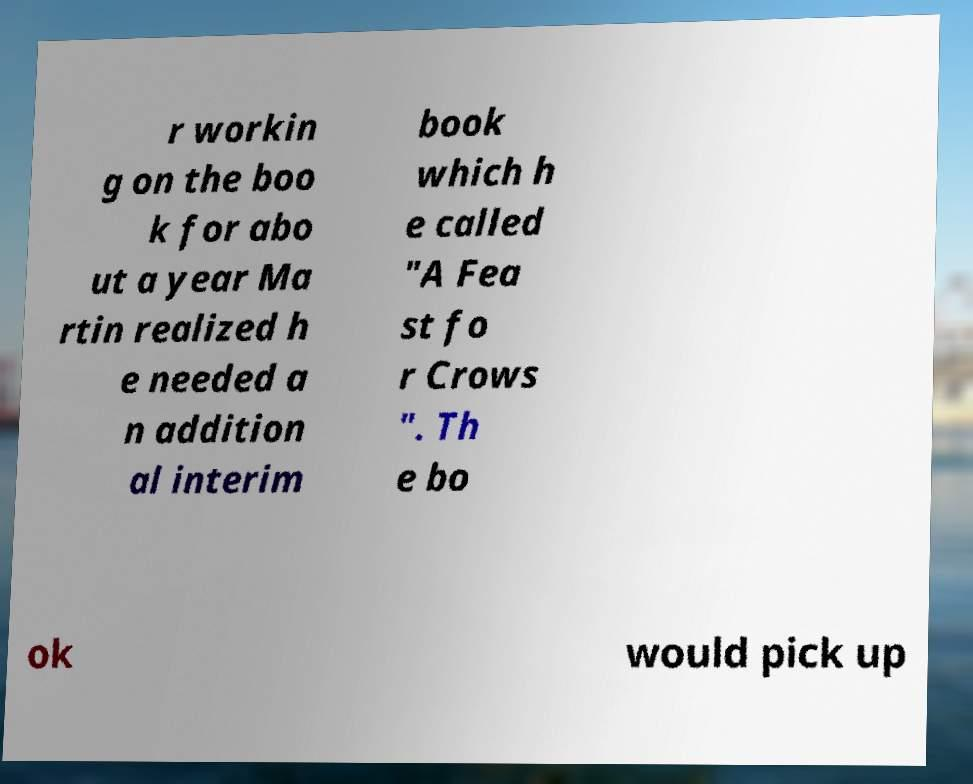Please identify and transcribe the text found in this image. r workin g on the boo k for abo ut a year Ma rtin realized h e needed a n addition al interim book which h e called "A Fea st fo r Crows ". Th e bo ok would pick up 